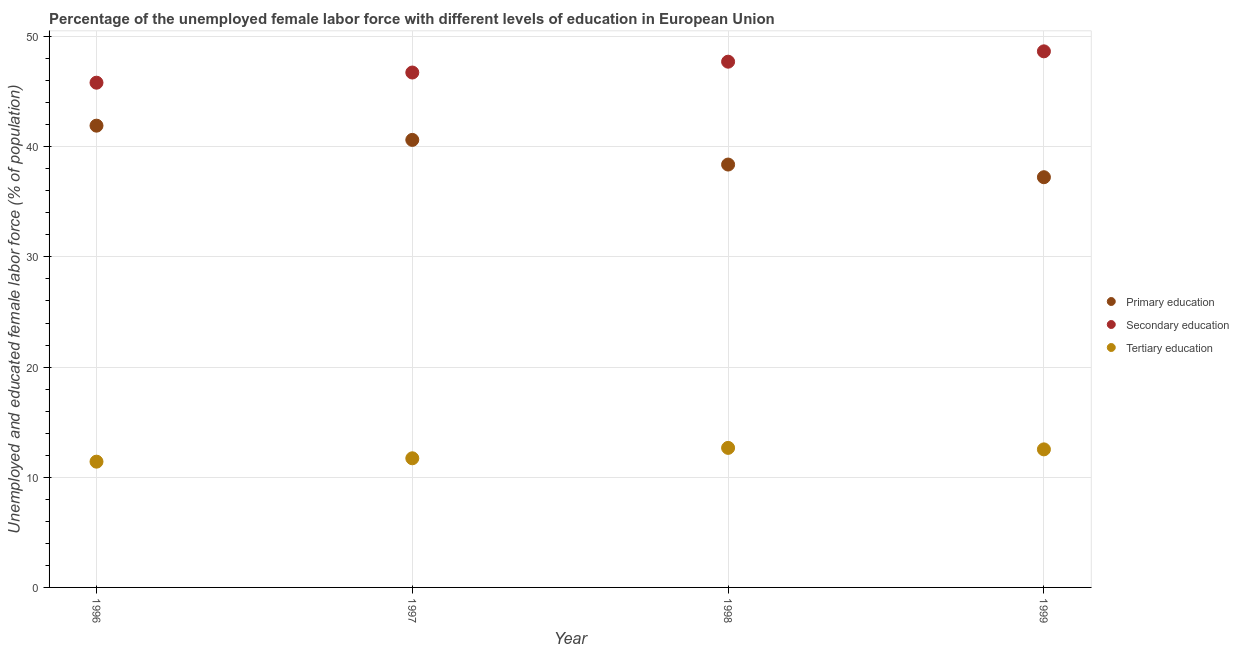What is the percentage of female labor force who received secondary education in 1997?
Your answer should be compact. 46.74. Across all years, what is the maximum percentage of female labor force who received primary education?
Your answer should be very brief. 41.92. Across all years, what is the minimum percentage of female labor force who received tertiary education?
Your response must be concise. 11.42. In which year was the percentage of female labor force who received primary education maximum?
Provide a succinct answer. 1996. In which year was the percentage of female labor force who received tertiary education minimum?
Offer a very short reply. 1996. What is the total percentage of female labor force who received secondary education in the graph?
Your answer should be compact. 188.94. What is the difference between the percentage of female labor force who received secondary education in 1998 and that in 1999?
Your answer should be compact. -0.94. What is the difference between the percentage of female labor force who received secondary education in 1999 and the percentage of female labor force who received tertiary education in 1996?
Provide a succinct answer. 37.25. What is the average percentage of female labor force who received tertiary education per year?
Provide a succinct answer. 12.08. In the year 1999, what is the difference between the percentage of female labor force who received tertiary education and percentage of female labor force who received secondary education?
Give a very brief answer. -36.13. What is the ratio of the percentage of female labor force who received primary education in 1996 to that in 1998?
Your response must be concise. 1.09. Is the percentage of female labor force who received secondary education in 1997 less than that in 1999?
Give a very brief answer. Yes. Is the difference between the percentage of female labor force who received primary education in 1996 and 1997 greater than the difference between the percentage of female labor force who received secondary education in 1996 and 1997?
Your response must be concise. Yes. What is the difference between the highest and the second highest percentage of female labor force who received tertiary education?
Make the answer very short. 0.14. What is the difference between the highest and the lowest percentage of female labor force who received tertiary education?
Your answer should be very brief. 1.25. Does the percentage of female labor force who received tertiary education monotonically increase over the years?
Give a very brief answer. No. Is the percentage of female labor force who received secondary education strictly less than the percentage of female labor force who received tertiary education over the years?
Offer a very short reply. No. How many dotlines are there?
Keep it short and to the point. 3. What is the difference between two consecutive major ticks on the Y-axis?
Your response must be concise. 10. Are the values on the major ticks of Y-axis written in scientific E-notation?
Ensure brevity in your answer.  No. Where does the legend appear in the graph?
Keep it short and to the point. Center right. What is the title of the graph?
Ensure brevity in your answer.  Percentage of the unemployed female labor force with different levels of education in European Union. What is the label or title of the X-axis?
Make the answer very short. Year. What is the label or title of the Y-axis?
Ensure brevity in your answer.  Unemployed and educated female labor force (% of population). What is the Unemployed and educated female labor force (% of population) of Primary education in 1996?
Your answer should be very brief. 41.92. What is the Unemployed and educated female labor force (% of population) of Secondary education in 1996?
Your answer should be very brief. 45.82. What is the Unemployed and educated female labor force (% of population) in Tertiary education in 1996?
Offer a terse response. 11.42. What is the Unemployed and educated female labor force (% of population) of Primary education in 1997?
Provide a succinct answer. 40.62. What is the Unemployed and educated female labor force (% of population) of Secondary education in 1997?
Your answer should be very brief. 46.74. What is the Unemployed and educated female labor force (% of population) of Tertiary education in 1997?
Provide a short and direct response. 11.72. What is the Unemployed and educated female labor force (% of population) of Primary education in 1998?
Your response must be concise. 38.39. What is the Unemployed and educated female labor force (% of population) of Secondary education in 1998?
Offer a very short reply. 47.72. What is the Unemployed and educated female labor force (% of population) of Tertiary education in 1998?
Your answer should be very brief. 12.67. What is the Unemployed and educated female labor force (% of population) in Primary education in 1999?
Provide a short and direct response. 37.24. What is the Unemployed and educated female labor force (% of population) of Secondary education in 1999?
Offer a very short reply. 48.66. What is the Unemployed and educated female labor force (% of population) in Tertiary education in 1999?
Give a very brief answer. 12.53. Across all years, what is the maximum Unemployed and educated female labor force (% of population) of Primary education?
Offer a terse response. 41.92. Across all years, what is the maximum Unemployed and educated female labor force (% of population) of Secondary education?
Provide a short and direct response. 48.66. Across all years, what is the maximum Unemployed and educated female labor force (% of population) in Tertiary education?
Ensure brevity in your answer.  12.67. Across all years, what is the minimum Unemployed and educated female labor force (% of population) in Primary education?
Keep it short and to the point. 37.24. Across all years, what is the minimum Unemployed and educated female labor force (% of population) of Secondary education?
Keep it short and to the point. 45.82. Across all years, what is the minimum Unemployed and educated female labor force (% of population) of Tertiary education?
Your answer should be compact. 11.42. What is the total Unemployed and educated female labor force (% of population) in Primary education in the graph?
Offer a terse response. 158.16. What is the total Unemployed and educated female labor force (% of population) of Secondary education in the graph?
Your response must be concise. 188.94. What is the total Unemployed and educated female labor force (% of population) of Tertiary education in the graph?
Your answer should be very brief. 48.34. What is the difference between the Unemployed and educated female labor force (% of population) in Primary education in 1996 and that in 1997?
Offer a terse response. 1.29. What is the difference between the Unemployed and educated female labor force (% of population) in Secondary education in 1996 and that in 1997?
Offer a terse response. -0.92. What is the difference between the Unemployed and educated female labor force (% of population) in Tertiary education in 1996 and that in 1997?
Make the answer very short. -0.31. What is the difference between the Unemployed and educated female labor force (% of population) in Primary education in 1996 and that in 1998?
Give a very brief answer. 3.53. What is the difference between the Unemployed and educated female labor force (% of population) in Secondary education in 1996 and that in 1998?
Provide a short and direct response. -1.91. What is the difference between the Unemployed and educated female labor force (% of population) in Tertiary education in 1996 and that in 1998?
Provide a short and direct response. -1.25. What is the difference between the Unemployed and educated female labor force (% of population) in Primary education in 1996 and that in 1999?
Your answer should be compact. 4.68. What is the difference between the Unemployed and educated female labor force (% of population) in Secondary education in 1996 and that in 1999?
Your answer should be compact. -2.85. What is the difference between the Unemployed and educated female labor force (% of population) of Tertiary education in 1996 and that in 1999?
Provide a short and direct response. -1.12. What is the difference between the Unemployed and educated female labor force (% of population) of Primary education in 1997 and that in 1998?
Ensure brevity in your answer.  2.24. What is the difference between the Unemployed and educated female labor force (% of population) of Secondary education in 1997 and that in 1998?
Provide a succinct answer. -0.98. What is the difference between the Unemployed and educated female labor force (% of population) in Tertiary education in 1997 and that in 1998?
Give a very brief answer. -0.94. What is the difference between the Unemployed and educated female labor force (% of population) in Primary education in 1997 and that in 1999?
Provide a succinct answer. 3.39. What is the difference between the Unemployed and educated female labor force (% of population) of Secondary education in 1997 and that in 1999?
Your answer should be compact. -1.92. What is the difference between the Unemployed and educated female labor force (% of population) of Tertiary education in 1997 and that in 1999?
Provide a succinct answer. -0.81. What is the difference between the Unemployed and educated female labor force (% of population) of Primary education in 1998 and that in 1999?
Your answer should be compact. 1.15. What is the difference between the Unemployed and educated female labor force (% of population) in Secondary education in 1998 and that in 1999?
Provide a succinct answer. -0.94. What is the difference between the Unemployed and educated female labor force (% of population) of Tertiary education in 1998 and that in 1999?
Provide a short and direct response. 0.14. What is the difference between the Unemployed and educated female labor force (% of population) of Primary education in 1996 and the Unemployed and educated female labor force (% of population) of Secondary education in 1997?
Provide a succinct answer. -4.82. What is the difference between the Unemployed and educated female labor force (% of population) of Primary education in 1996 and the Unemployed and educated female labor force (% of population) of Tertiary education in 1997?
Your response must be concise. 30.19. What is the difference between the Unemployed and educated female labor force (% of population) in Secondary education in 1996 and the Unemployed and educated female labor force (% of population) in Tertiary education in 1997?
Your answer should be very brief. 34.09. What is the difference between the Unemployed and educated female labor force (% of population) of Primary education in 1996 and the Unemployed and educated female labor force (% of population) of Secondary education in 1998?
Your response must be concise. -5.81. What is the difference between the Unemployed and educated female labor force (% of population) in Primary education in 1996 and the Unemployed and educated female labor force (% of population) in Tertiary education in 1998?
Make the answer very short. 29.25. What is the difference between the Unemployed and educated female labor force (% of population) of Secondary education in 1996 and the Unemployed and educated female labor force (% of population) of Tertiary education in 1998?
Your response must be concise. 33.15. What is the difference between the Unemployed and educated female labor force (% of population) of Primary education in 1996 and the Unemployed and educated female labor force (% of population) of Secondary education in 1999?
Your answer should be compact. -6.75. What is the difference between the Unemployed and educated female labor force (% of population) of Primary education in 1996 and the Unemployed and educated female labor force (% of population) of Tertiary education in 1999?
Provide a short and direct response. 29.38. What is the difference between the Unemployed and educated female labor force (% of population) of Secondary education in 1996 and the Unemployed and educated female labor force (% of population) of Tertiary education in 1999?
Offer a terse response. 33.28. What is the difference between the Unemployed and educated female labor force (% of population) in Primary education in 1997 and the Unemployed and educated female labor force (% of population) in Secondary education in 1998?
Ensure brevity in your answer.  -7.1. What is the difference between the Unemployed and educated female labor force (% of population) of Primary education in 1997 and the Unemployed and educated female labor force (% of population) of Tertiary education in 1998?
Your response must be concise. 27.96. What is the difference between the Unemployed and educated female labor force (% of population) of Secondary education in 1997 and the Unemployed and educated female labor force (% of population) of Tertiary education in 1998?
Make the answer very short. 34.07. What is the difference between the Unemployed and educated female labor force (% of population) of Primary education in 1997 and the Unemployed and educated female labor force (% of population) of Secondary education in 1999?
Your response must be concise. -8.04. What is the difference between the Unemployed and educated female labor force (% of population) of Primary education in 1997 and the Unemployed and educated female labor force (% of population) of Tertiary education in 1999?
Provide a succinct answer. 28.09. What is the difference between the Unemployed and educated female labor force (% of population) in Secondary education in 1997 and the Unemployed and educated female labor force (% of population) in Tertiary education in 1999?
Keep it short and to the point. 34.21. What is the difference between the Unemployed and educated female labor force (% of population) in Primary education in 1998 and the Unemployed and educated female labor force (% of population) in Secondary education in 1999?
Your answer should be compact. -10.28. What is the difference between the Unemployed and educated female labor force (% of population) in Primary education in 1998 and the Unemployed and educated female labor force (% of population) in Tertiary education in 1999?
Your answer should be very brief. 25.85. What is the difference between the Unemployed and educated female labor force (% of population) in Secondary education in 1998 and the Unemployed and educated female labor force (% of population) in Tertiary education in 1999?
Ensure brevity in your answer.  35.19. What is the average Unemployed and educated female labor force (% of population) of Primary education per year?
Your response must be concise. 39.54. What is the average Unemployed and educated female labor force (% of population) of Secondary education per year?
Give a very brief answer. 47.23. What is the average Unemployed and educated female labor force (% of population) of Tertiary education per year?
Give a very brief answer. 12.08. In the year 1996, what is the difference between the Unemployed and educated female labor force (% of population) of Primary education and Unemployed and educated female labor force (% of population) of Secondary education?
Provide a succinct answer. -3.9. In the year 1996, what is the difference between the Unemployed and educated female labor force (% of population) in Primary education and Unemployed and educated female labor force (% of population) in Tertiary education?
Offer a very short reply. 30.5. In the year 1996, what is the difference between the Unemployed and educated female labor force (% of population) in Secondary education and Unemployed and educated female labor force (% of population) in Tertiary education?
Keep it short and to the point. 34.4. In the year 1997, what is the difference between the Unemployed and educated female labor force (% of population) of Primary education and Unemployed and educated female labor force (% of population) of Secondary education?
Provide a succinct answer. -6.12. In the year 1997, what is the difference between the Unemployed and educated female labor force (% of population) in Primary education and Unemployed and educated female labor force (% of population) in Tertiary education?
Provide a short and direct response. 28.9. In the year 1997, what is the difference between the Unemployed and educated female labor force (% of population) in Secondary education and Unemployed and educated female labor force (% of population) in Tertiary education?
Offer a terse response. 35.02. In the year 1998, what is the difference between the Unemployed and educated female labor force (% of population) of Primary education and Unemployed and educated female labor force (% of population) of Secondary education?
Your answer should be compact. -9.34. In the year 1998, what is the difference between the Unemployed and educated female labor force (% of population) in Primary education and Unemployed and educated female labor force (% of population) in Tertiary education?
Offer a very short reply. 25.72. In the year 1998, what is the difference between the Unemployed and educated female labor force (% of population) in Secondary education and Unemployed and educated female labor force (% of population) in Tertiary education?
Offer a terse response. 35.06. In the year 1999, what is the difference between the Unemployed and educated female labor force (% of population) of Primary education and Unemployed and educated female labor force (% of population) of Secondary education?
Offer a very short reply. -11.43. In the year 1999, what is the difference between the Unemployed and educated female labor force (% of population) of Primary education and Unemployed and educated female labor force (% of population) of Tertiary education?
Provide a short and direct response. 24.7. In the year 1999, what is the difference between the Unemployed and educated female labor force (% of population) of Secondary education and Unemployed and educated female labor force (% of population) of Tertiary education?
Make the answer very short. 36.13. What is the ratio of the Unemployed and educated female labor force (% of population) in Primary education in 1996 to that in 1997?
Your answer should be very brief. 1.03. What is the ratio of the Unemployed and educated female labor force (% of population) in Secondary education in 1996 to that in 1997?
Your answer should be very brief. 0.98. What is the ratio of the Unemployed and educated female labor force (% of population) of Tertiary education in 1996 to that in 1997?
Your answer should be very brief. 0.97. What is the ratio of the Unemployed and educated female labor force (% of population) in Primary education in 1996 to that in 1998?
Ensure brevity in your answer.  1.09. What is the ratio of the Unemployed and educated female labor force (% of population) of Secondary education in 1996 to that in 1998?
Your answer should be compact. 0.96. What is the ratio of the Unemployed and educated female labor force (% of population) in Tertiary education in 1996 to that in 1998?
Provide a short and direct response. 0.9. What is the ratio of the Unemployed and educated female labor force (% of population) in Primary education in 1996 to that in 1999?
Your answer should be very brief. 1.13. What is the ratio of the Unemployed and educated female labor force (% of population) of Secondary education in 1996 to that in 1999?
Provide a succinct answer. 0.94. What is the ratio of the Unemployed and educated female labor force (% of population) of Tertiary education in 1996 to that in 1999?
Your answer should be very brief. 0.91. What is the ratio of the Unemployed and educated female labor force (% of population) in Primary education in 1997 to that in 1998?
Make the answer very short. 1.06. What is the ratio of the Unemployed and educated female labor force (% of population) of Secondary education in 1997 to that in 1998?
Provide a succinct answer. 0.98. What is the ratio of the Unemployed and educated female labor force (% of population) in Tertiary education in 1997 to that in 1998?
Ensure brevity in your answer.  0.93. What is the ratio of the Unemployed and educated female labor force (% of population) in Primary education in 1997 to that in 1999?
Keep it short and to the point. 1.09. What is the ratio of the Unemployed and educated female labor force (% of population) of Secondary education in 1997 to that in 1999?
Provide a short and direct response. 0.96. What is the ratio of the Unemployed and educated female labor force (% of population) in Tertiary education in 1997 to that in 1999?
Your answer should be compact. 0.94. What is the ratio of the Unemployed and educated female labor force (% of population) of Primary education in 1998 to that in 1999?
Your answer should be very brief. 1.03. What is the ratio of the Unemployed and educated female labor force (% of population) in Secondary education in 1998 to that in 1999?
Provide a short and direct response. 0.98. What is the ratio of the Unemployed and educated female labor force (% of population) in Tertiary education in 1998 to that in 1999?
Keep it short and to the point. 1.01. What is the difference between the highest and the second highest Unemployed and educated female labor force (% of population) in Primary education?
Provide a succinct answer. 1.29. What is the difference between the highest and the second highest Unemployed and educated female labor force (% of population) of Secondary education?
Your answer should be very brief. 0.94. What is the difference between the highest and the second highest Unemployed and educated female labor force (% of population) in Tertiary education?
Offer a terse response. 0.14. What is the difference between the highest and the lowest Unemployed and educated female labor force (% of population) of Primary education?
Offer a very short reply. 4.68. What is the difference between the highest and the lowest Unemployed and educated female labor force (% of population) of Secondary education?
Offer a very short reply. 2.85. What is the difference between the highest and the lowest Unemployed and educated female labor force (% of population) in Tertiary education?
Provide a short and direct response. 1.25. 